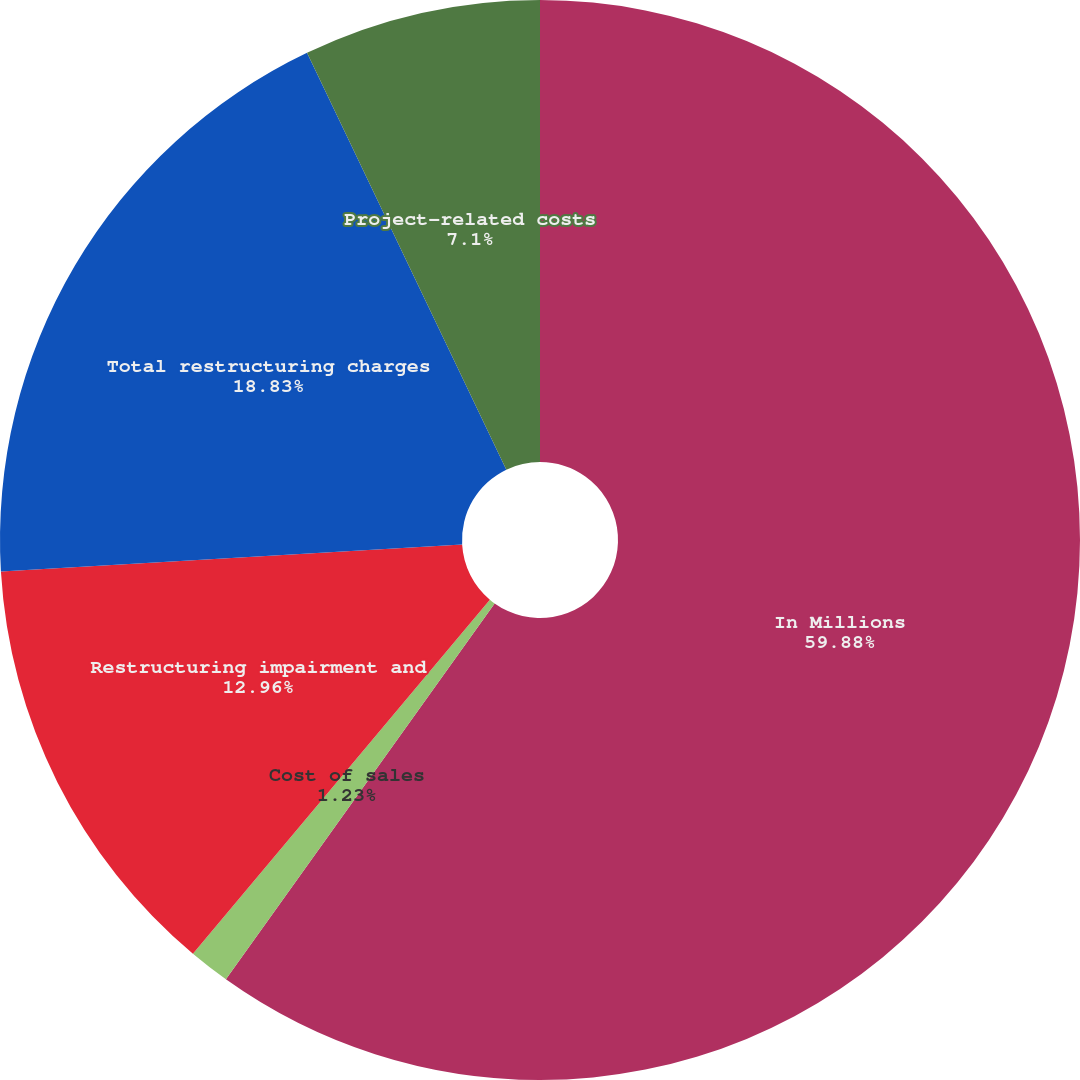Convert chart to OTSL. <chart><loc_0><loc_0><loc_500><loc_500><pie_chart><fcel>In Millions<fcel>Cost of sales<fcel>Restructuring impairment and<fcel>Total restructuring charges<fcel>Project-related costs<nl><fcel>59.88%<fcel>1.23%<fcel>12.96%<fcel>18.83%<fcel>7.1%<nl></chart> 